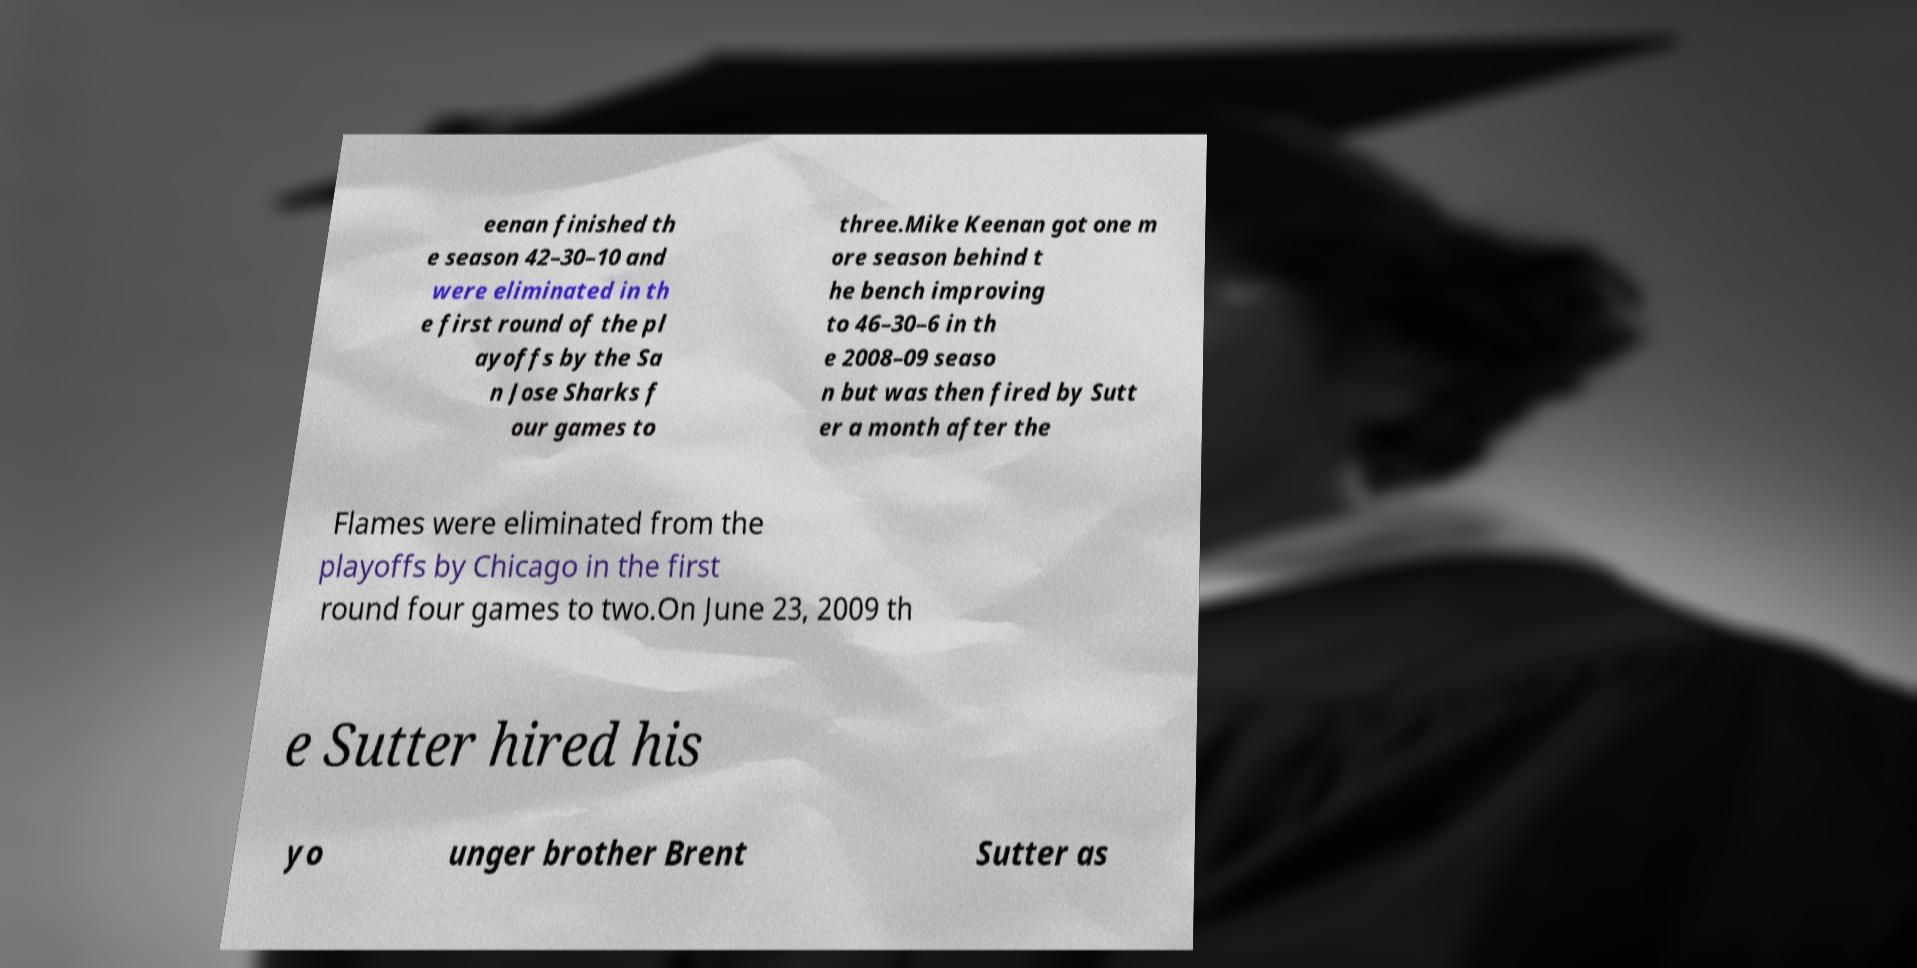What messages or text are displayed in this image? I need them in a readable, typed format. eenan finished th e season 42–30–10 and were eliminated in th e first round of the pl ayoffs by the Sa n Jose Sharks f our games to three.Mike Keenan got one m ore season behind t he bench improving to 46–30–6 in th e 2008–09 seaso n but was then fired by Sutt er a month after the Flames were eliminated from the playoffs by Chicago in the first round four games to two.On June 23, 2009 th e Sutter hired his yo unger brother Brent Sutter as 